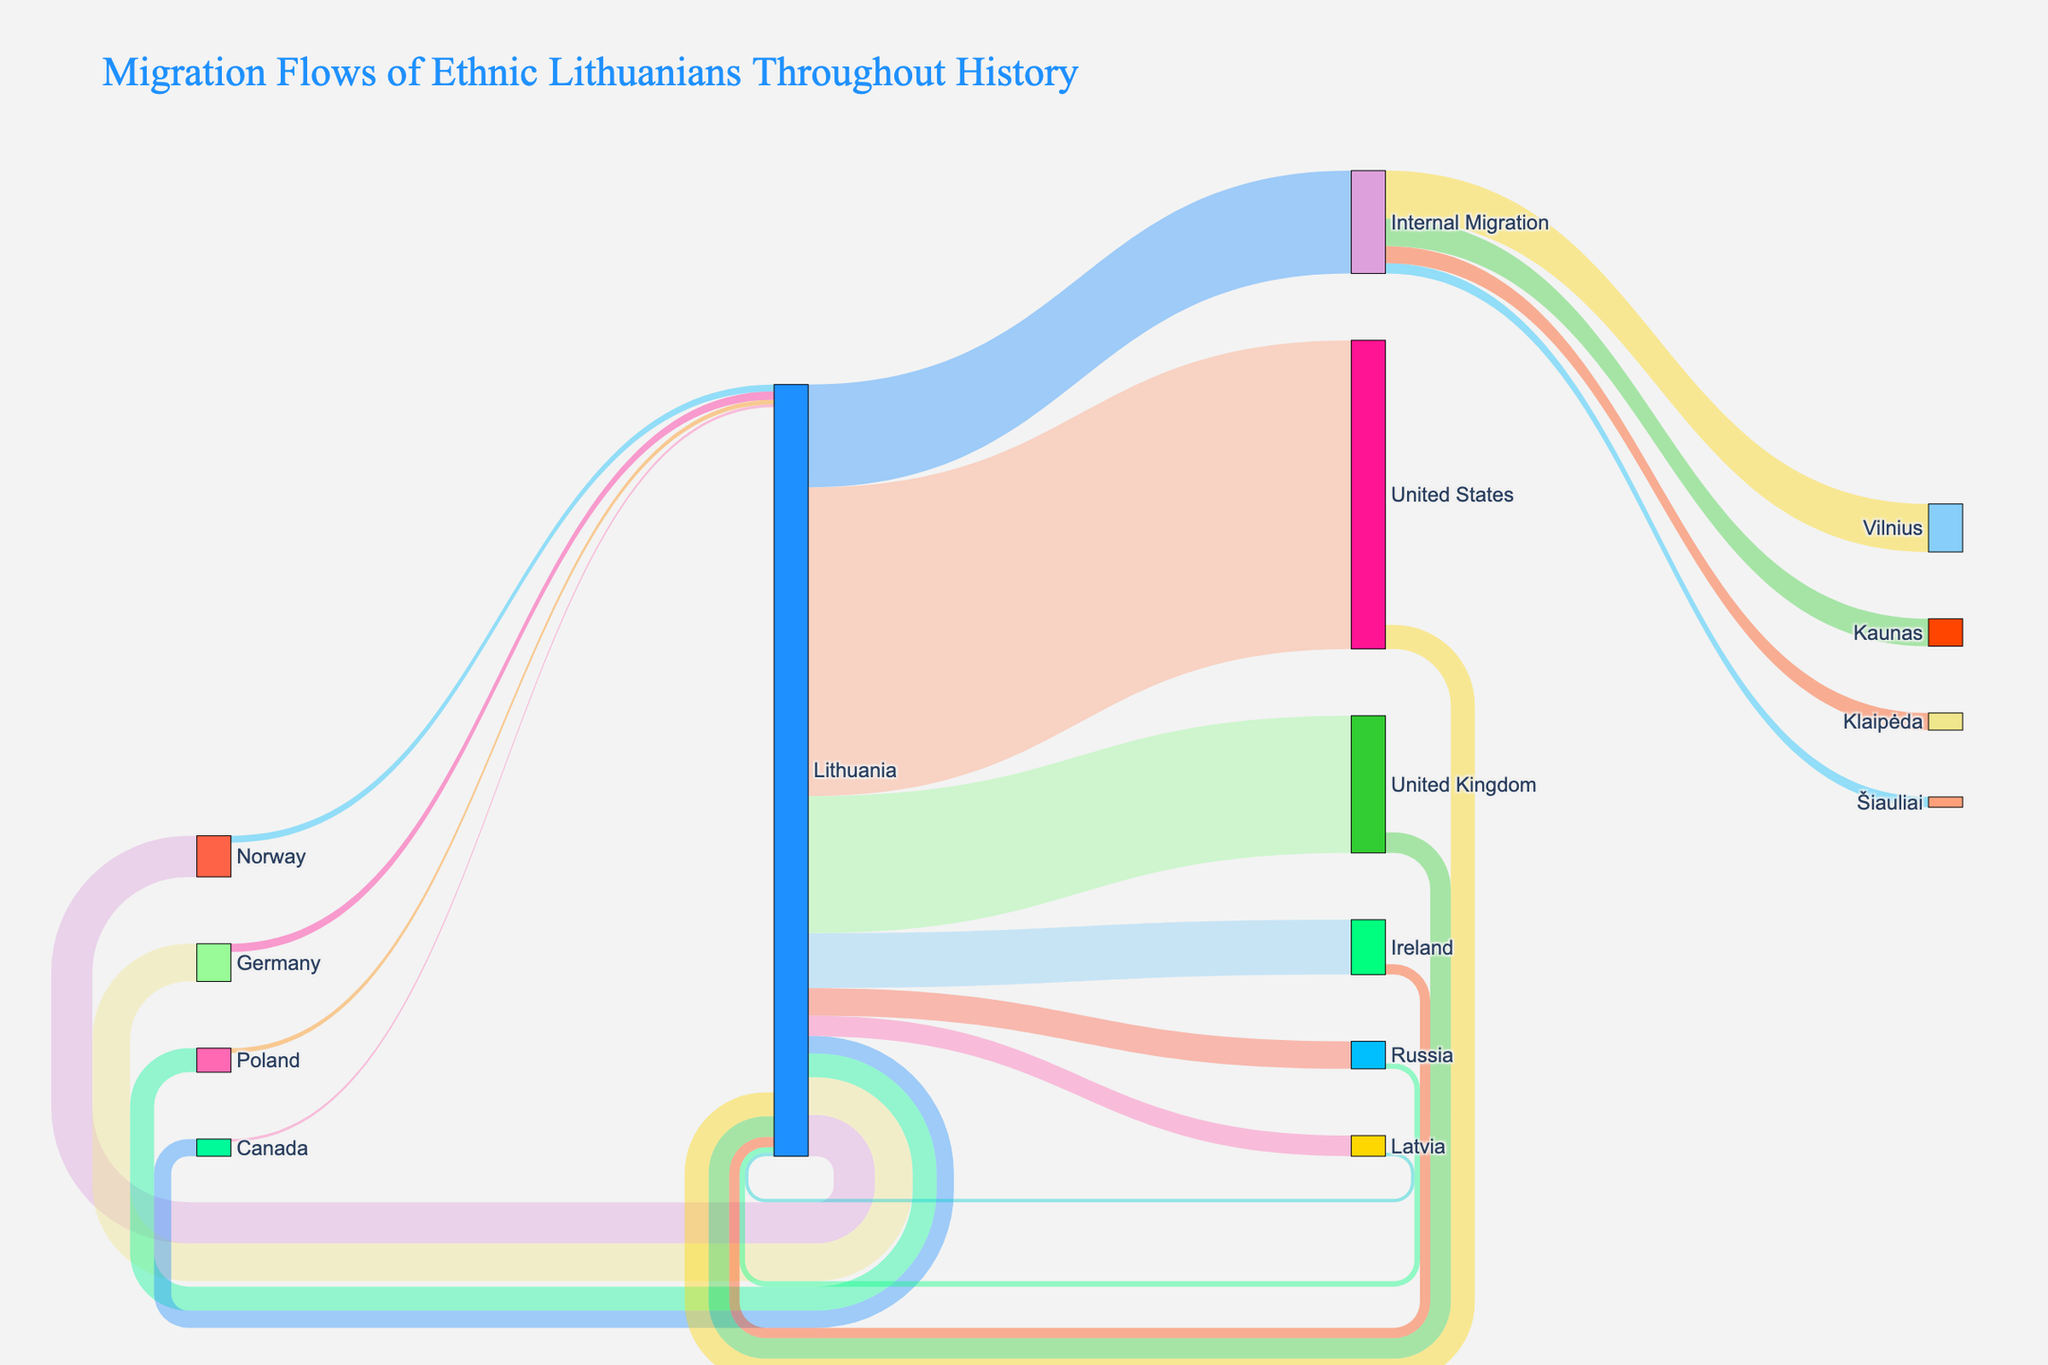Which destination has the highest migration flow from Lithuania? The highest migration flow from Lithuania is represented by the thickest arrow. By examining the diagram, the flow to the United States appears to be the thickest, indicating the largest migration.
Answer: United States What is the total number of ethnic Lithuanian emigrants shown in the diagram? Sum the values of all emigration flows from Lithuania: 450,000 (United States) + 200,000 (United Kingdom) + 80,000 (Ireland) + 60,000 (Norway) + 55,000 (Germany) + 40,000 (Russia) + 35,000 (Poland) + 30,000 (Latvia) + 25,000 (Canada) + 150,000 (Internal Migration) = 1,125,000.
Answer: 1,125,000 Which country has the highest number of ethnic Lithuanians returning from abroad? By examining the arrows going to Lithuania, the United States has the highest return flow represented by 35,000.
Answer: United States How does the number of Lithuanian emigrants to the United Kingdom compare to those emigrating to Poland? Compare the values for the United Kingdom (200,000) and Poland (35,000). The number of emigrants to the United Kingdom is significantly higher.
Answer: United Kingdom has more What proportion of internal migration flows to Vilnius compared to the total internal migration? Internal migration flows to Vilnius and other cities are: Vilnius (70,000), Kaunas (40,000), Klaipėda (25,000), Šiauliai (15,000). The total internal migration is 70,000 + 40,000 + 25,000 + 15,000 = 150,000. The proportion for Vilnius is 70,000 / 150,000 = 0.467, approximately 46.7%.
Answer: 46.7% Which is the smallest migration flow returning to Lithuania and from which country? By examining the smallest returning arrows to Lithuania, the flow from Canada is the smallest with 4,000.
Answer: Canada Is the number of Lithuanians migrating to Norway larger than to Germany? Compare the values: 60,000 (Norway) and 55,000 (Germany). Yes, the number migrating to Norway is larger.
Answer: Yes What is the overall migration balance for ethnic Lithuanians between Lithuania and Ireland? (Emigration vs. Return) Emigration from Lithuania to Ireland is 80,000 and the return is 15,000. The balance: 80,000 - 15,000 = 65,000.
Answer: 65,000 How many ethnic Lithuanians are involved in the combined migration flows between Lithuania and Germany? Sum the emigration (55,000) and return migration (12,000) flows to get 55,000 + 12,000. Combined, this is 67,000.
Answer: 67,000 Is the return migration flow from Norway to Lithuania greater than that from Latvia? Compare the values: 10,000 (Norway) and 5,000 (Latvia). Yes, the return flow from Norway is greater.
Answer: Yes 